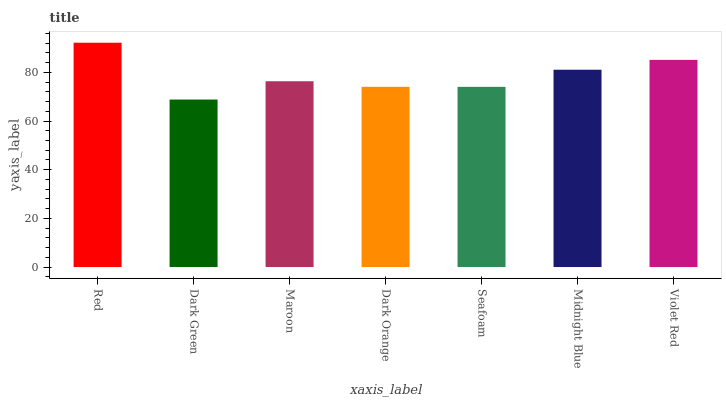Is Dark Green the minimum?
Answer yes or no. Yes. Is Red the maximum?
Answer yes or no. Yes. Is Maroon the minimum?
Answer yes or no. No. Is Maroon the maximum?
Answer yes or no. No. Is Maroon greater than Dark Green?
Answer yes or no. Yes. Is Dark Green less than Maroon?
Answer yes or no. Yes. Is Dark Green greater than Maroon?
Answer yes or no. No. Is Maroon less than Dark Green?
Answer yes or no. No. Is Maroon the high median?
Answer yes or no. Yes. Is Maroon the low median?
Answer yes or no. Yes. Is Seafoam the high median?
Answer yes or no. No. Is Dark Green the low median?
Answer yes or no. No. 